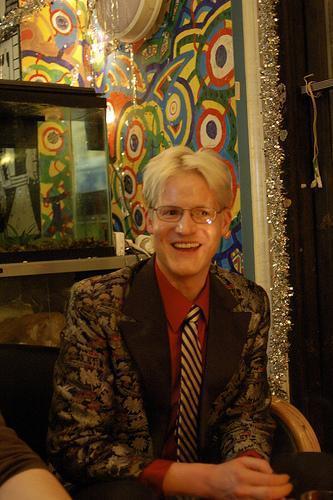How many people are pictured?
Give a very brief answer. 1. 